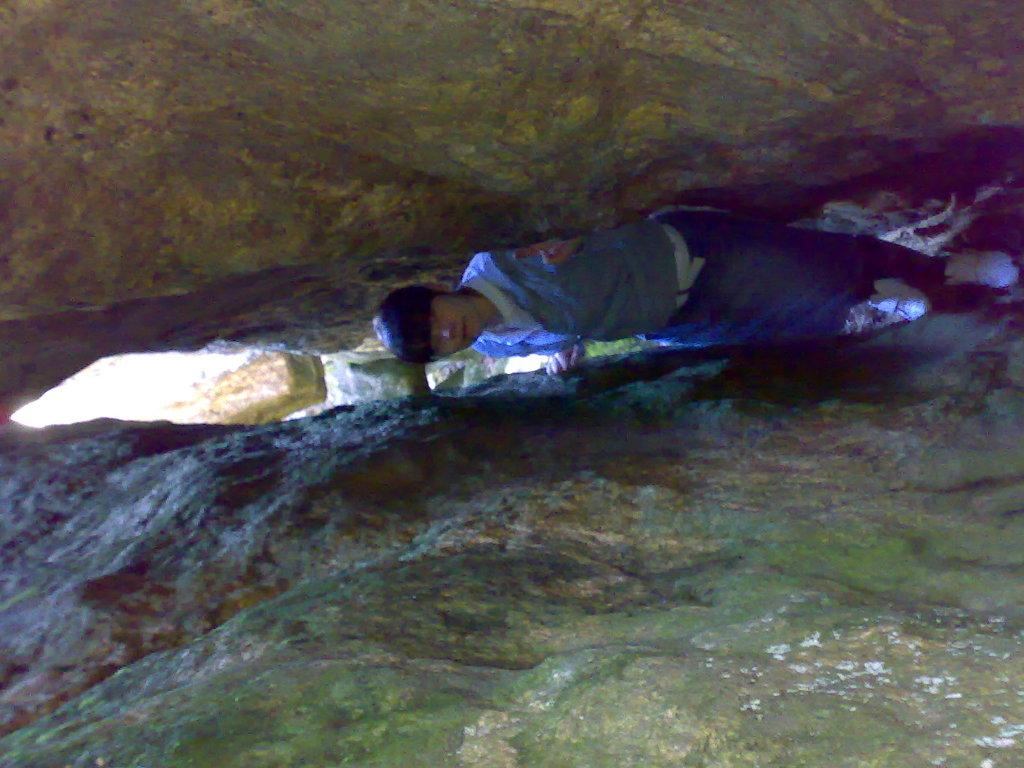What is the main subject in the center of the image? There is a person standing in the center of the image. What type of terrain is visible in the image? There are rocks at the top and bottom of the image. How does the person in the image give a thumb kiss to the rocks at the top? There is no indication in the image that the person is giving a thumb kiss to the rocks at the top, as the person is standing and the rocks are at the top of the image. 